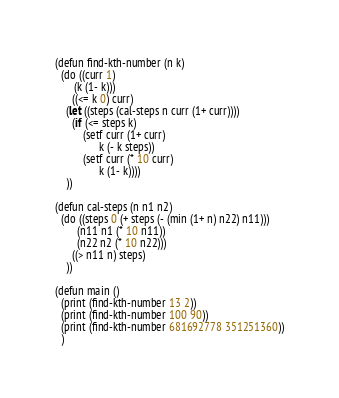Convert code to text. <code><loc_0><loc_0><loc_500><loc_500><_Lisp_>(defun find-kth-number (n k)
  (do ((curr 1)
       (k (1- k)))
      ((<= k 0) curr)
    (let ((steps (cal-steps n curr (1+ curr))))
      (if (<= steps k)
          (setf curr (1+ curr)
                k (- k steps))
          (setf curr (* 10 curr)
                k (1- k))))
    ))

(defun cal-steps (n n1 n2)
  (do ((steps 0 (+ steps (- (min (1+ n) n22) n11)))
        (n11 n1 (* 10 n11))
        (n22 n2 (* 10 n22)))
      ((> n11 n) steps)
    ))

(defun main ()
  (print (find-kth-number 13 2)) 
  (print (find-kth-number 100 90))
  (print (find-kth-number 681692778 351251360))
  )
</code> 